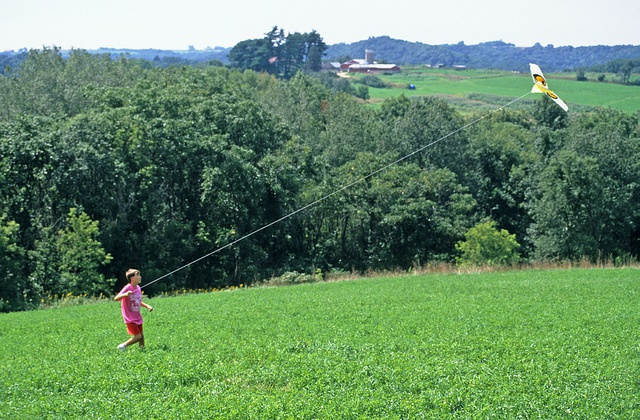Describe the objects in this image and their specific colors. I can see people in white, purple, brown, violet, and maroon tones and kite in white, khaki, and darkgray tones in this image. 